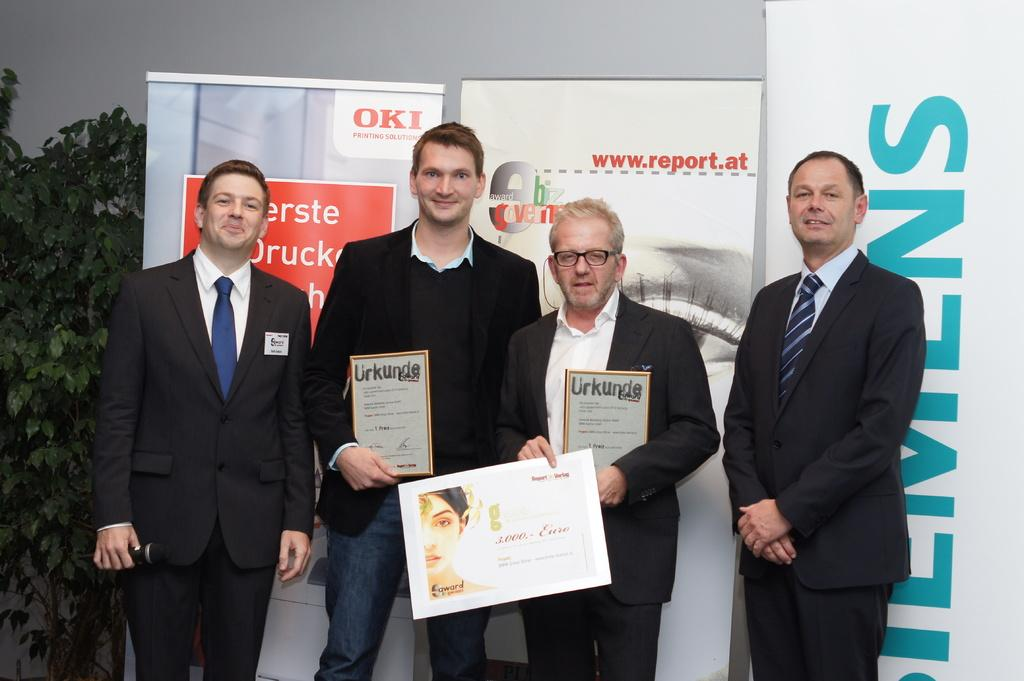How many people are in the image wearing suits? There are four people wearing suits in the image. What are the people in the image doing? The four people are standing. What are two of the people holding in the image? Two of the people are holding certificates. What can be seen in the background of the image? There is a plant and hoardings in the background of the image. How does the plant in the background care for the people in the image? The plant in the background does not care for the people in the image; it is a separate element in the background. 